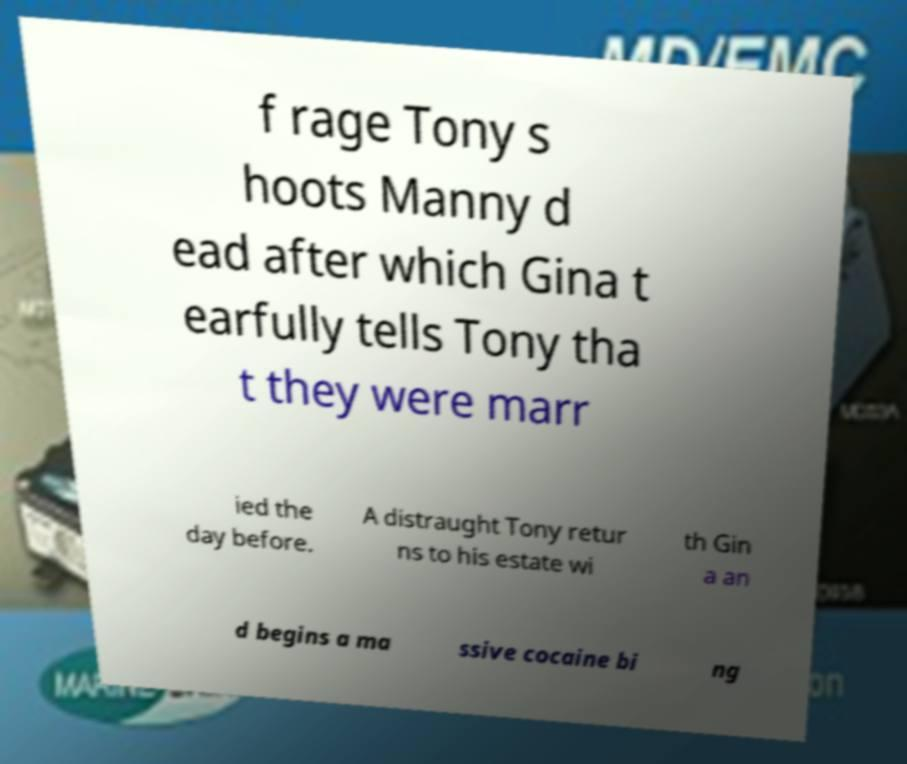For documentation purposes, I need the text within this image transcribed. Could you provide that? f rage Tony s hoots Manny d ead after which Gina t earfully tells Tony tha t they were marr ied the day before. A distraught Tony retur ns to his estate wi th Gin a an d begins a ma ssive cocaine bi ng 